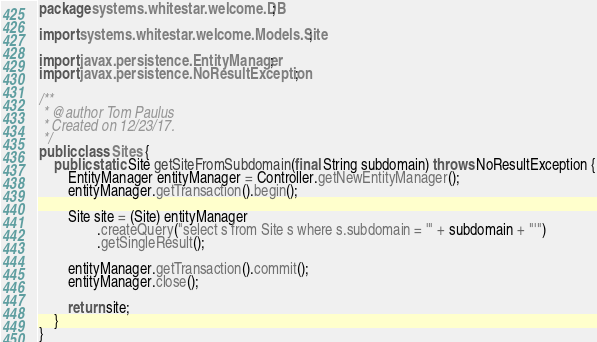Convert code to text. <code><loc_0><loc_0><loc_500><loc_500><_Java_>package systems.whitestar.welcome.DB;

import systems.whitestar.welcome.Models.Site;

import javax.persistence.EntityManager;
import javax.persistence.NoResultException;

/**
 * @author Tom Paulus
 * Created on 12/23/17.
 */
public class Sites {
    public static Site getSiteFromSubdomain(final String subdomain) throws NoResultException {
        EntityManager entityManager = Controller.getNewEntityManager();
        entityManager.getTransaction().begin();

        Site site = (Site) entityManager
                .createQuery("select s from Site s where s.subdomain = '" + subdomain + "'")
                .getSingleResult();

        entityManager.getTransaction().commit();
        entityManager.close();

        return site;
    }
}
</code> 